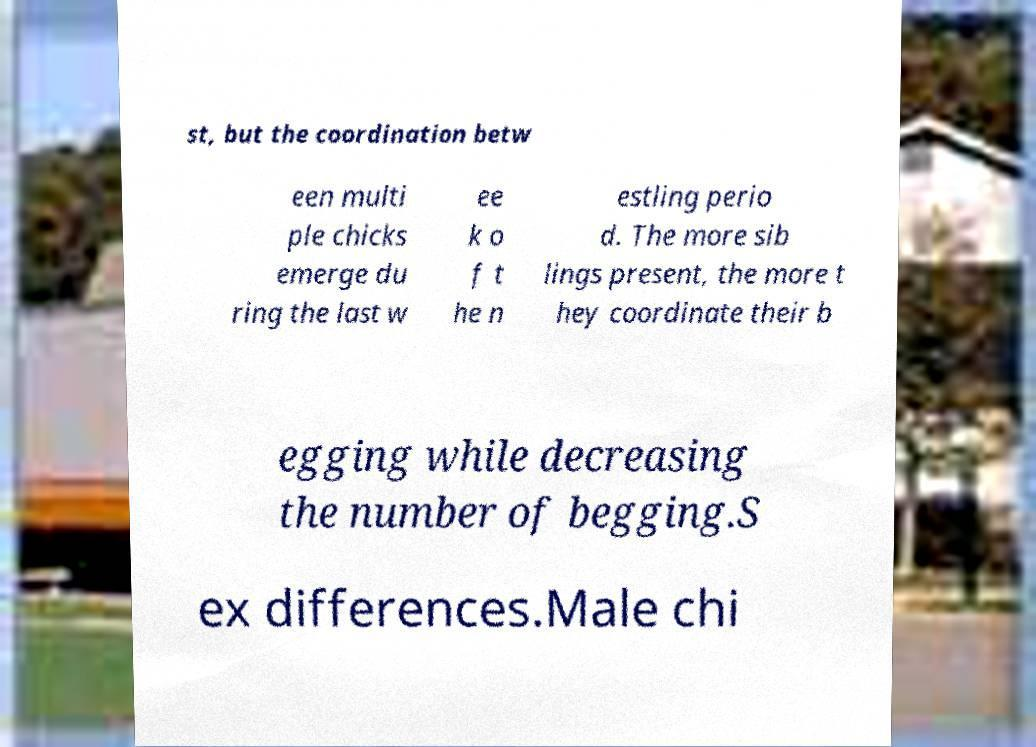Could you extract and type out the text from this image? st, but the coordination betw een multi ple chicks emerge du ring the last w ee k o f t he n estling perio d. The more sib lings present, the more t hey coordinate their b egging while decreasing the number of begging.S ex differences.Male chi 